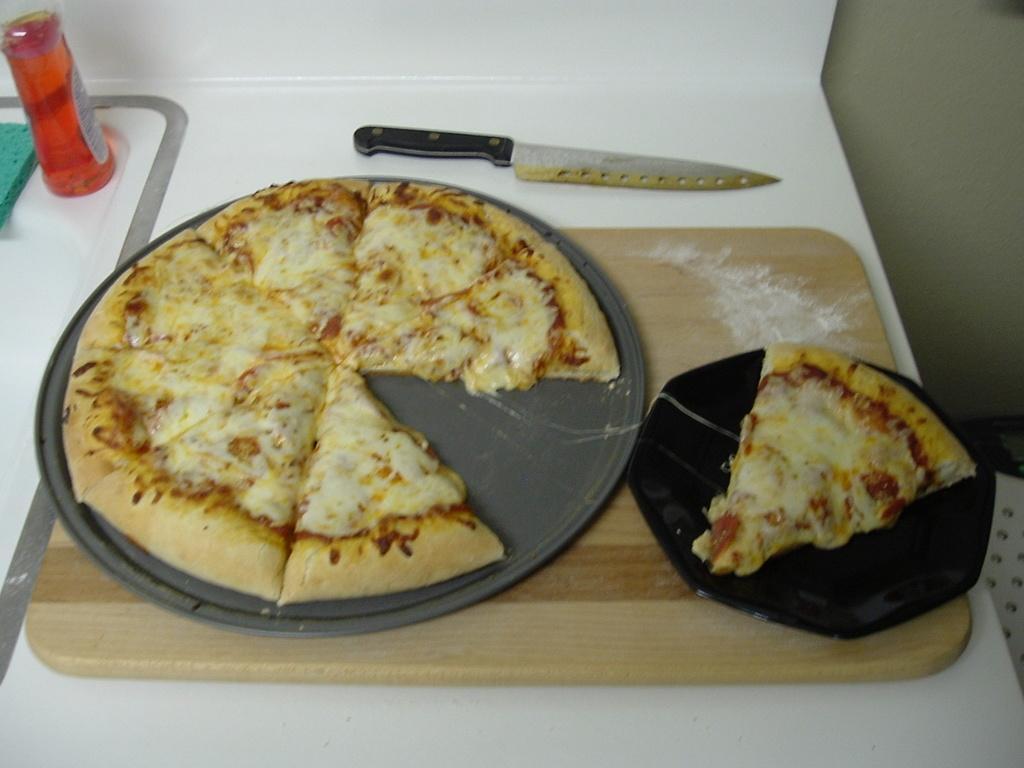Describe this image in one or two sentences. This image in the center there is food and there is a knife. On the left side there is a bottle and there is an object which is green in colour and there is a wooden plank. 